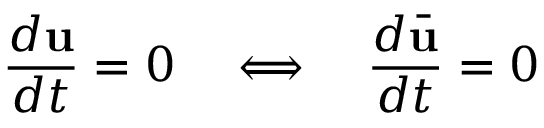Convert formula to latex. <formula><loc_0><loc_0><loc_500><loc_500>\frac { d u } { d t } = 0 \quad \Longleftrightarrow \quad \frac { d \bar { u } } { d t } = 0</formula> 